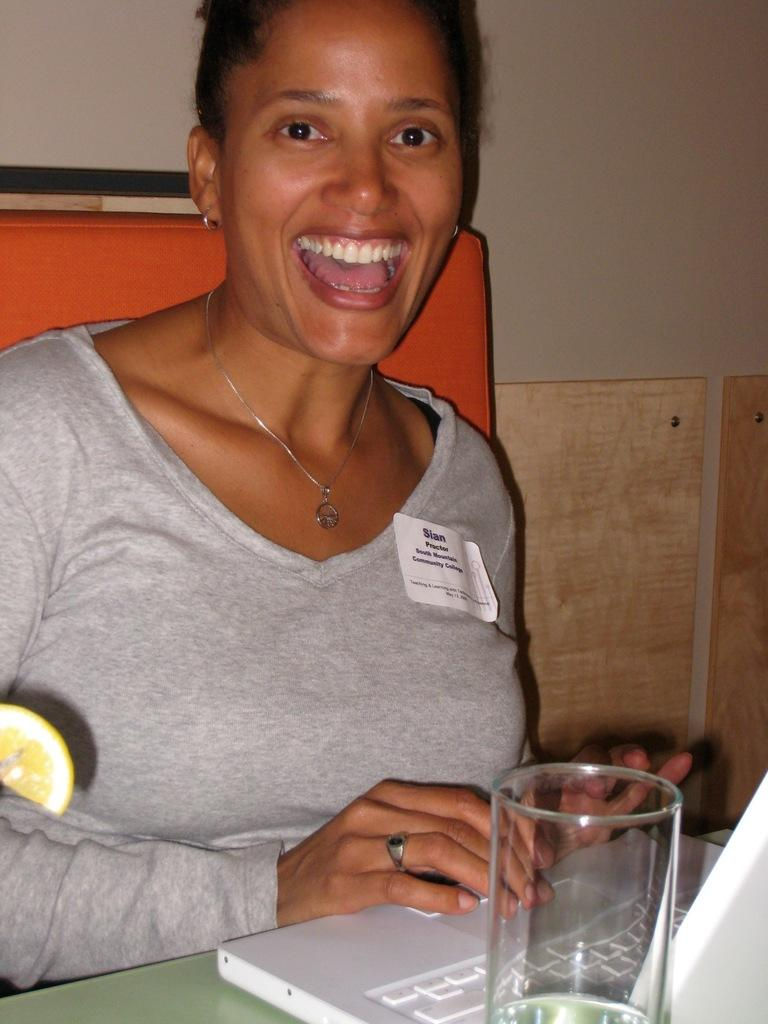What is located in the foreground of the image? There is a table in the foreground of the image. What electronic device is on the table? A laptop is present on the table. What is in the glass on the table? There is a lemon slice visible in the glass. What is the woman in the image doing? The woman is sitting in a chair and smiling. What can be seen in the background of the image? There is a wall visible in the background of the image. Can you tell me how many ducks are present in the image? There are no ducks present in the image. What type of animal is sitting next to the woman in the image? There is no animal present in the image; only a woman is visible. 